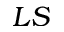Convert formula to latex. <formula><loc_0><loc_0><loc_500><loc_500>L S</formula> 